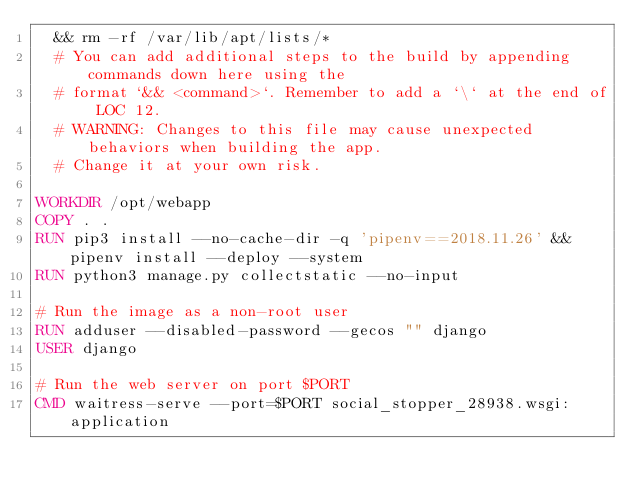<code> <loc_0><loc_0><loc_500><loc_500><_Dockerfile_>  && rm -rf /var/lib/apt/lists/*
  # You can add additional steps to the build by appending commands down here using the
  # format `&& <command>`. Remember to add a `\` at the end of LOC 12.
  # WARNING: Changes to this file may cause unexpected behaviors when building the app.
  # Change it at your own risk.

WORKDIR /opt/webapp
COPY . .
RUN pip3 install --no-cache-dir -q 'pipenv==2018.11.26' && pipenv install --deploy --system
RUN python3 manage.py collectstatic --no-input

# Run the image as a non-root user
RUN adduser --disabled-password --gecos "" django
USER django

# Run the web server on port $PORT
CMD waitress-serve --port=$PORT social_stopper_28938.wsgi:application
</code> 